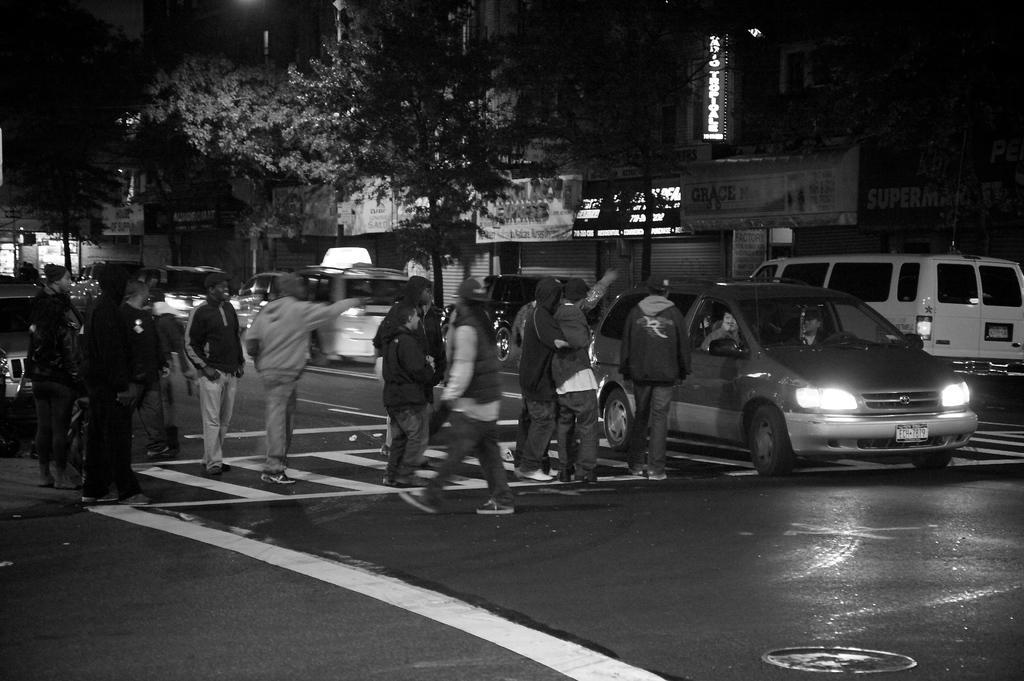Describe this image in one or two sentences. In this picture we can see a group of people crossing road on zebra crossing where some persons are in car on road and in background we can see trees, building, banners. 